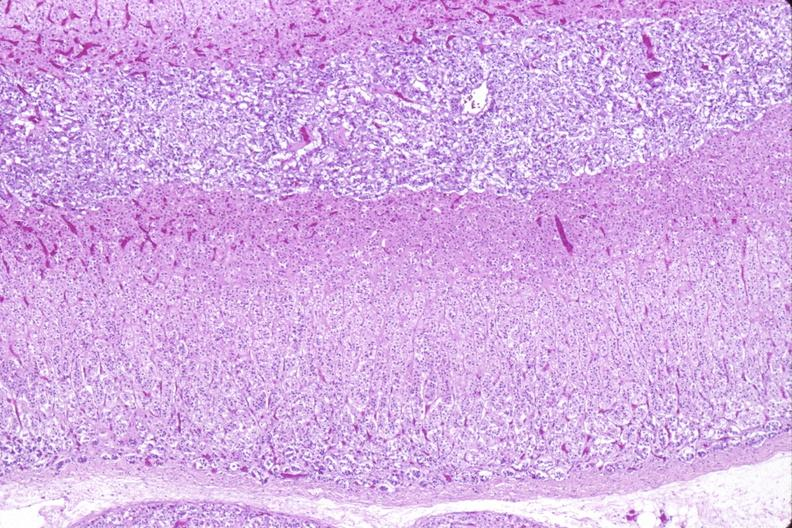does this image show adrenal gland, normal histology?
Answer the question using a single word or phrase. Yes 